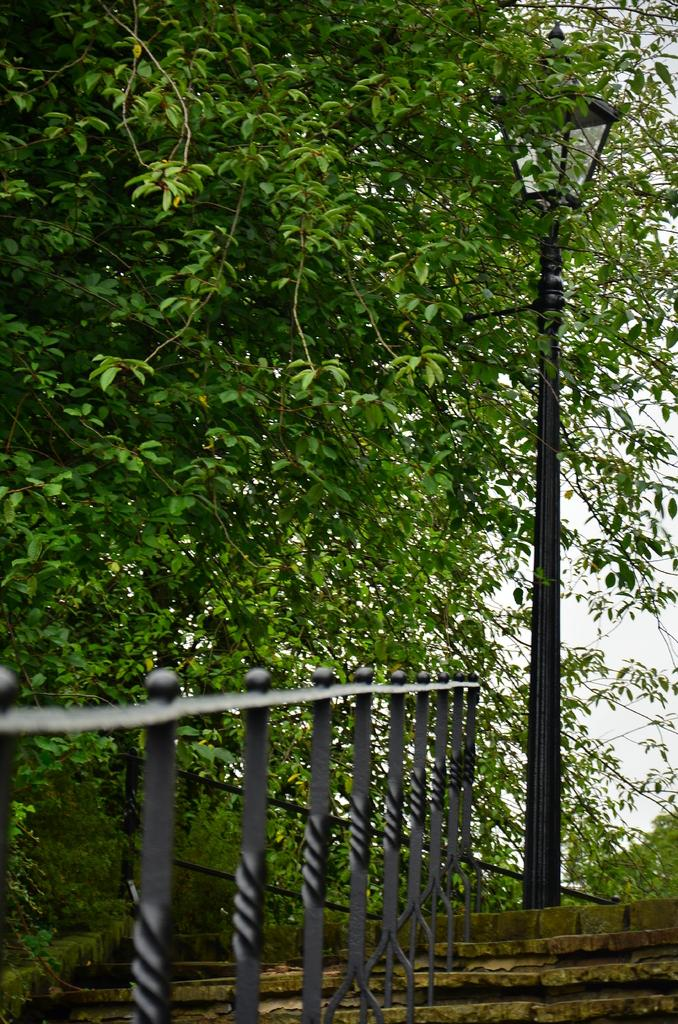What is located at the bottom of the image? There is a staircase at the bottom of the image. What can be seen on the left side of the image? There is an iron railing and trees on the left side of the image. What is on the right side of the image? There is a lamp on the right side of the image. What type of yarn is being used to create the railing on the left side of the image? There is no yarn present in the image; the railing is made of iron. How does the stick in the image move from one side to the other? There is no stick present in the image, so it cannot move. 